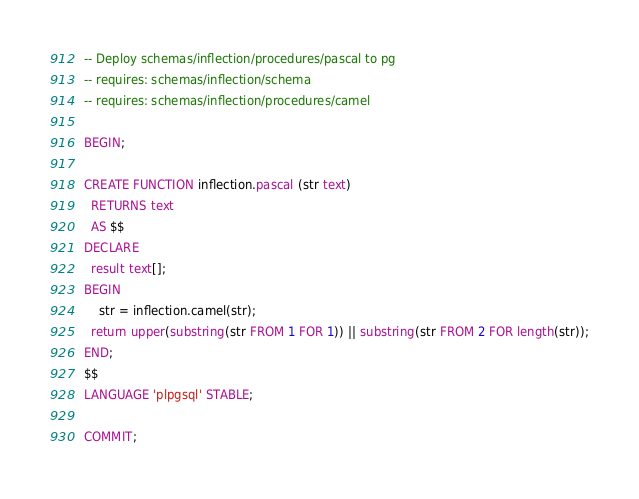<code> <loc_0><loc_0><loc_500><loc_500><_SQL_>-- Deploy schemas/inflection/procedures/pascal to pg
-- requires: schemas/inflection/schema
-- requires: schemas/inflection/procedures/camel

BEGIN;

CREATE FUNCTION inflection.pascal (str text)
  RETURNS text
  AS $$
DECLARE
  result text[];
BEGIN
    str = inflection.camel(str);
  return upper(substring(str FROM 1 FOR 1)) || substring(str FROM 2 FOR length(str));
END;
$$
LANGUAGE 'plpgsql' STABLE;

COMMIT;

</code> 